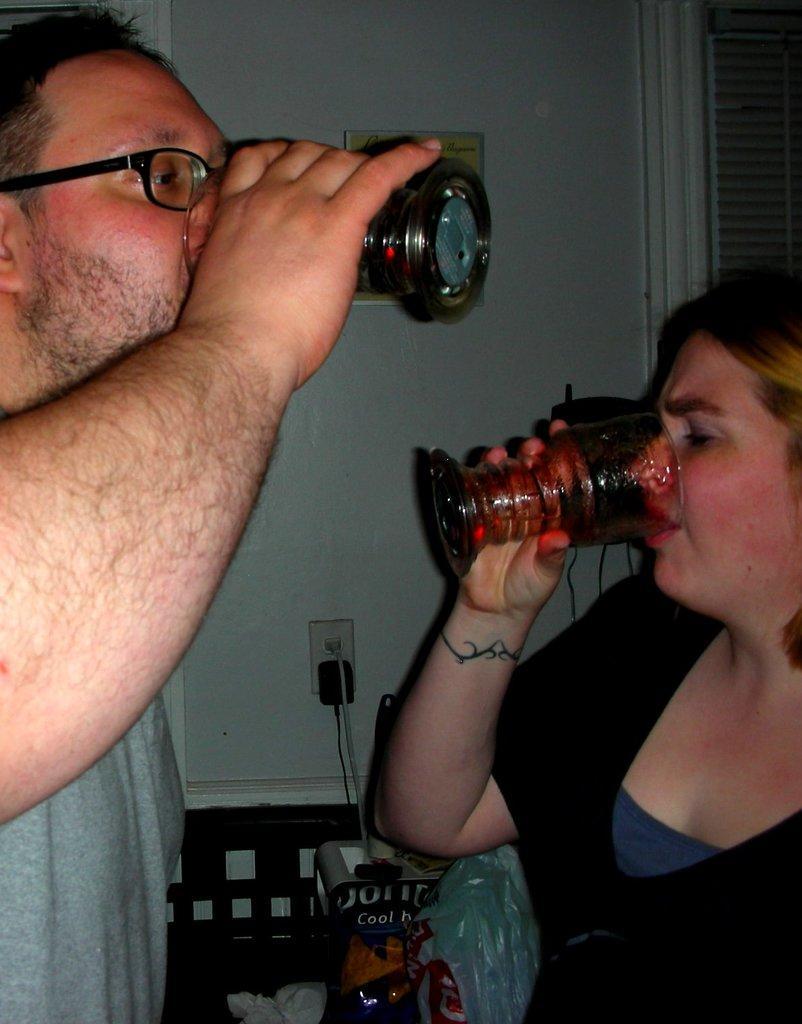Describe this image in one or two sentences. In this image there is a man and a woman holding glasses in their hands. They are drinking. Behind them there are objects on a chair. There is a wall in the image. There are adapters to the power socket. There is a picture frame on the wall. 